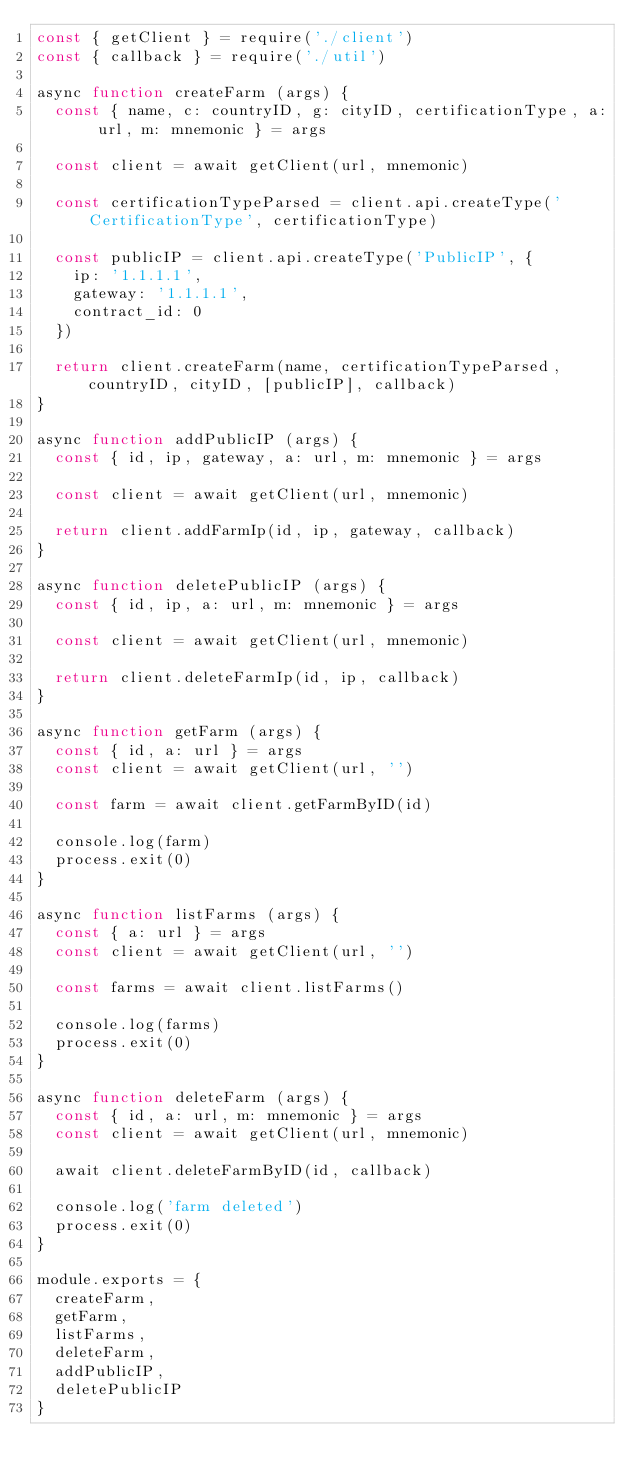<code> <loc_0><loc_0><loc_500><loc_500><_JavaScript_>const { getClient } = require('./client')
const { callback } = require('./util')

async function createFarm (args) {
  const { name, c: countryID, g: cityID, certificationType, a: url, m: mnemonic } = args

  const client = await getClient(url, mnemonic)

  const certificationTypeParsed = client.api.createType('CertificationType', certificationType)

  const publicIP = client.api.createType('PublicIP', {
    ip: '1.1.1.1',
    gateway: '1.1.1.1',
    contract_id: 0
  })

  return client.createFarm(name, certificationTypeParsed, countryID, cityID, [publicIP], callback)
}

async function addPublicIP (args) {
  const { id, ip, gateway, a: url, m: mnemonic } = args

  const client = await getClient(url, mnemonic)

  return client.addFarmIp(id, ip, gateway, callback)
}

async function deletePublicIP (args) {
  const { id, ip, a: url, m: mnemonic } = args

  const client = await getClient(url, mnemonic)

  return client.deleteFarmIp(id, ip, callback)
}

async function getFarm (args) {
  const { id, a: url } = args
  const client = await getClient(url, '')

  const farm = await client.getFarmByID(id)

  console.log(farm)
  process.exit(0)
}

async function listFarms (args) {
  const { a: url } = args
  const client = await getClient(url, '')

  const farms = await client.listFarms()

  console.log(farms)
  process.exit(0)
}

async function deleteFarm (args) {
  const { id, a: url, m: mnemonic } = args
  const client = await getClient(url, mnemonic)

  await client.deleteFarmByID(id, callback)

  console.log('farm deleted')
  process.exit(0)
}

module.exports = {
  createFarm,
  getFarm,
  listFarms,
  deleteFarm,
  addPublicIP,
  deletePublicIP
}
</code> 